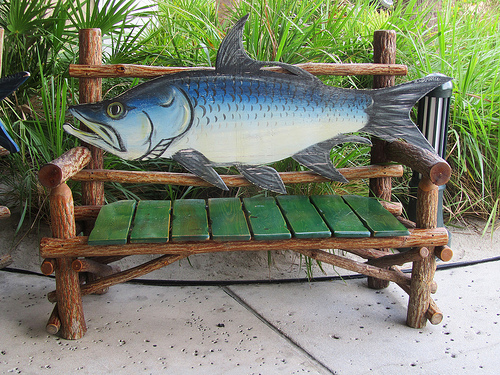<image>
Is there a grass behind the floor? Yes. From this viewpoint, the grass is positioned behind the floor, with the floor partially or fully occluding the grass. Where is the fish in relation to the bench? Is it in front of the bench? No. The fish is not in front of the bench. The spatial positioning shows a different relationship between these objects. 